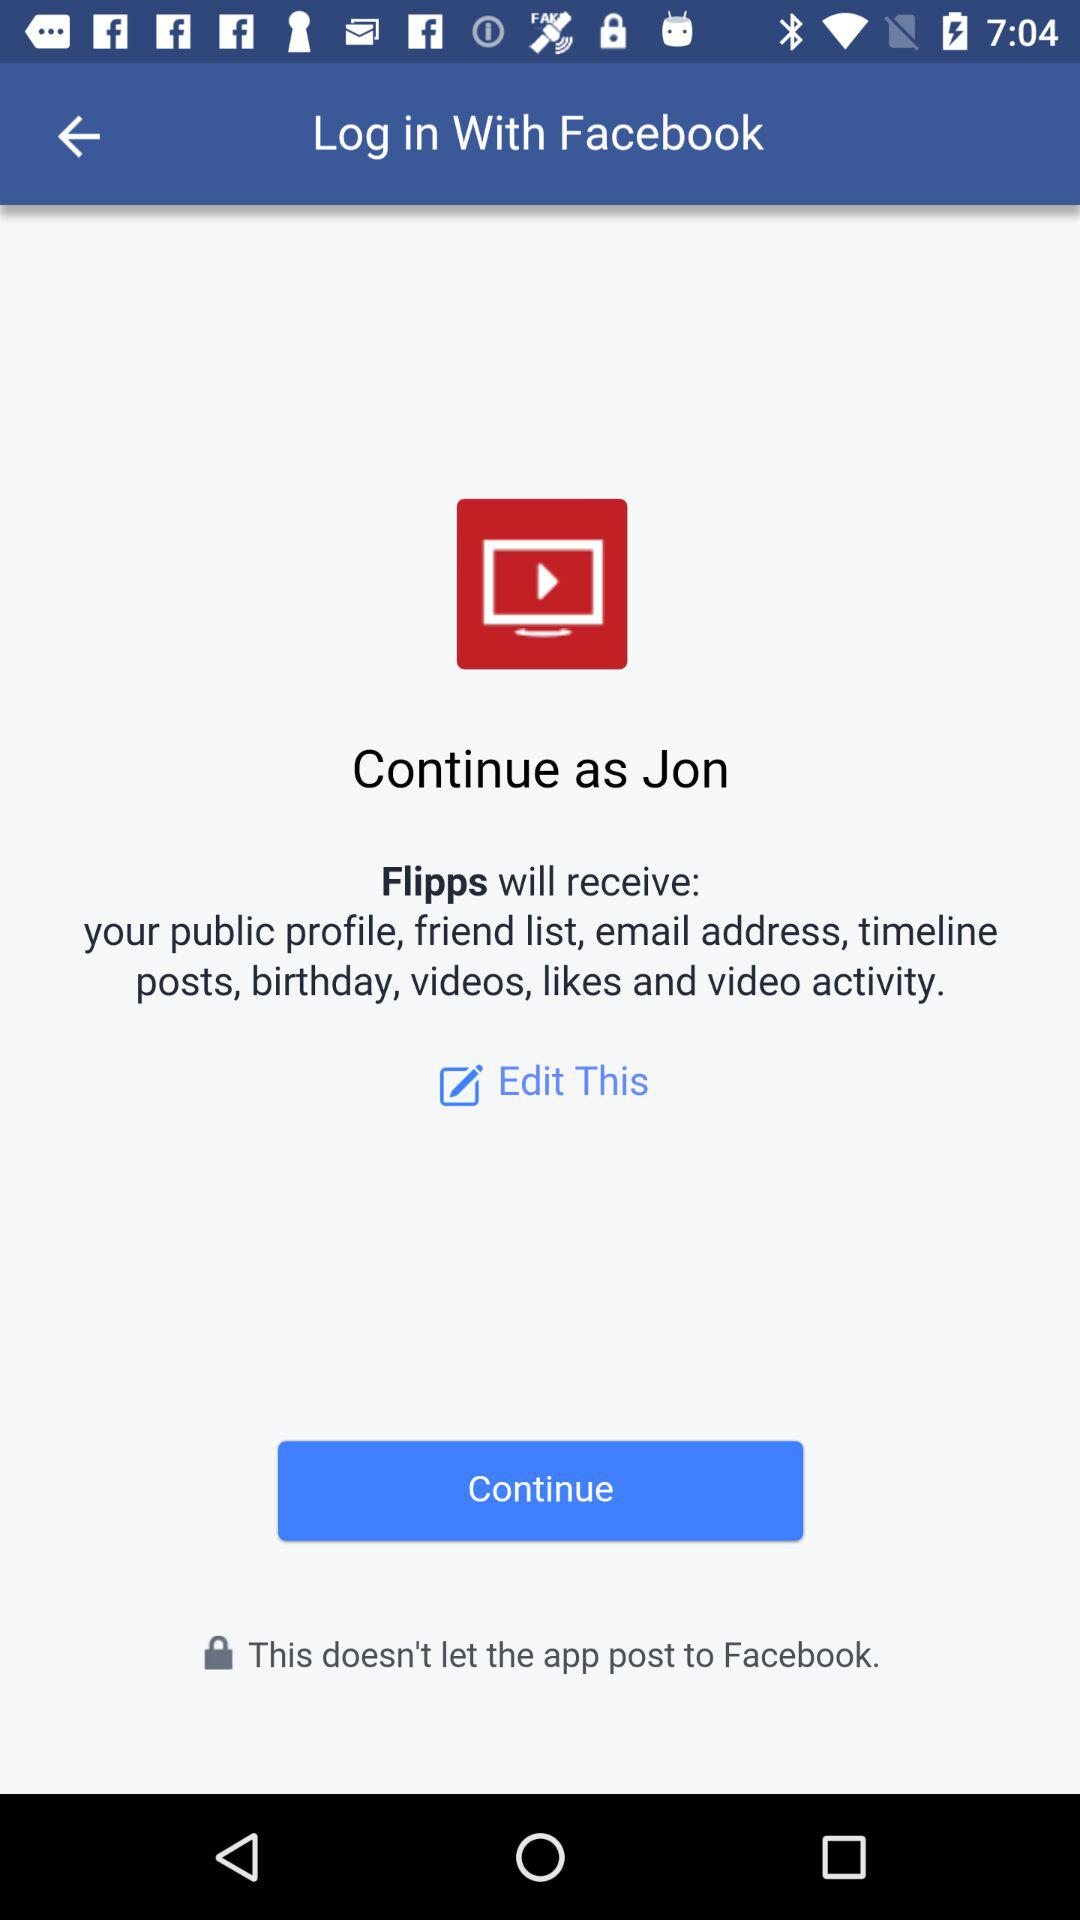Which option is selected?
When the provided information is insufficient, respond with <no answer>. <no answer> 